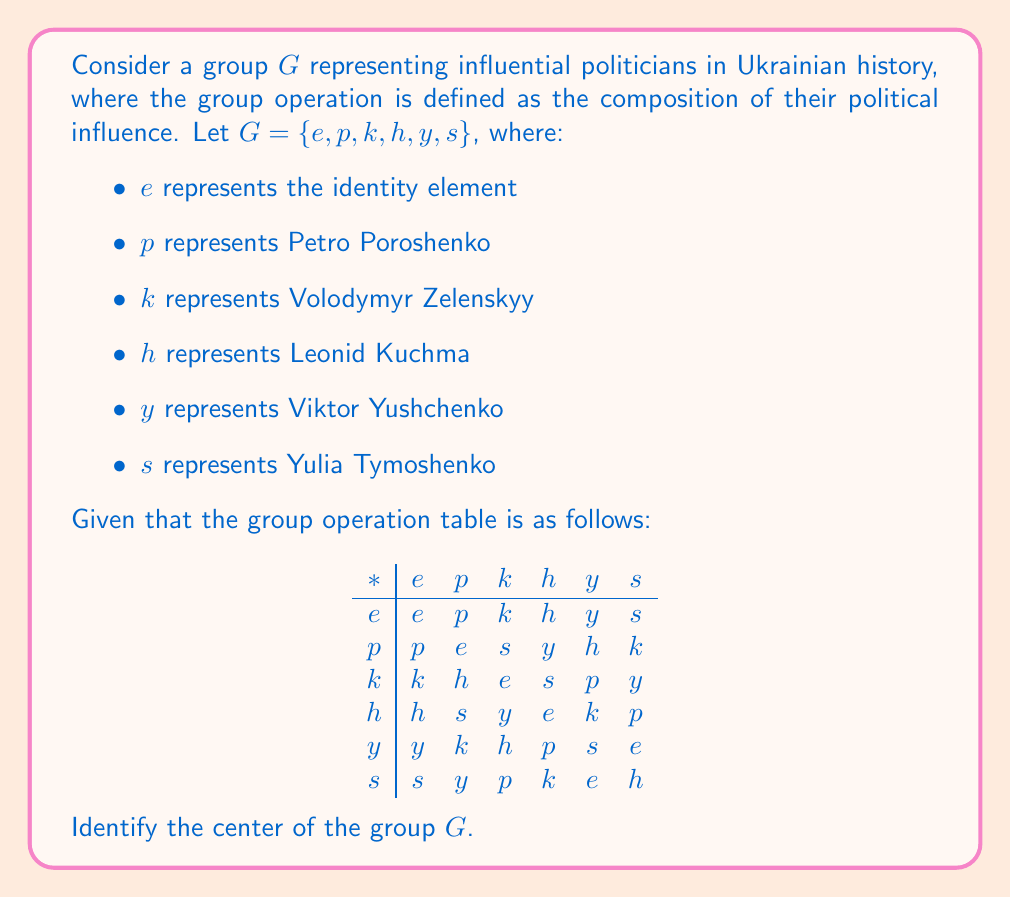Give your solution to this math problem. To solve this problem, we need to understand the concept of the center of a group and then apply it to the given group of Ukrainian politicians.

1. The center of a group $G$, denoted as $Z(G)$, is the set of all elements in $G$ that commute with every element of $G$. In other words:

   $Z(G) = \{a \in G : ax = xa \text{ for all } x \in G\}$

2. To find the center, we need to check which elements commute with all other elements in the group.

3. Let's start with the identity element $e$:
   - $e$ commutes with all elements (as expected for the identity).

4. Now, let's check each of the other elements:

   For $p$:
   - $p * k = s \neq h = k * p$
   - $p$ does not commute with $k$, so it's not in the center.

   For $k$:
   - $k * p = h \neq s = p * k$
   - $k$ does not commute with $p$, so it's not in the center.

   For $h$:
   - $h * p = s \neq y = p * h$
   - $h$ does not commute with $p$, so it's not in the center.

   For $y$:
   - $y * p = k \neq h = p * y$
   - $y$ does not commute with $p$, so it's not in the center.

   For $s$:
   - $s * p = y \neq k = p * s$
   - $s$ does not commute with $p$, so it's not in the center.

5. After checking all elements, we find that only the identity element $e$ commutes with all other elements in the group.

Therefore, the center of the group $G$ consists only of the identity element $e$.
Answer: $Z(G) = \{e\}$ 